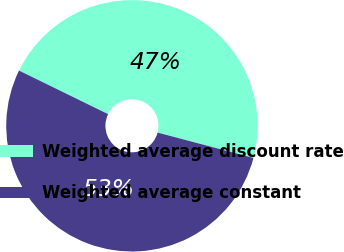<chart> <loc_0><loc_0><loc_500><loc_500><pie_chart><fcel>Weighted average discount rate<fcel>Weighted average constant<nl><fcel>46.88%<fcel>53.12%<nl></chart> 